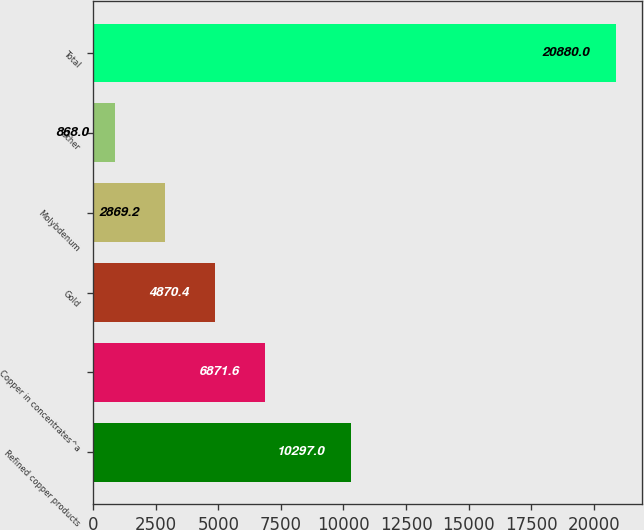Convert chart to OTSL. <chart><loc_0><loc_0><loc_500><loc_500><bar_chart><fcel>Refined copper products<fcel>Copper in concentrates^a<fcel>Gold<fcel>Molybdenum<fcel>Other<fcel>Total<nl><fcel>10297<fcel>6871.6<fcel>4870.4<fcel>2869.2<fcel>868<fcel>20880<nl></chart> 